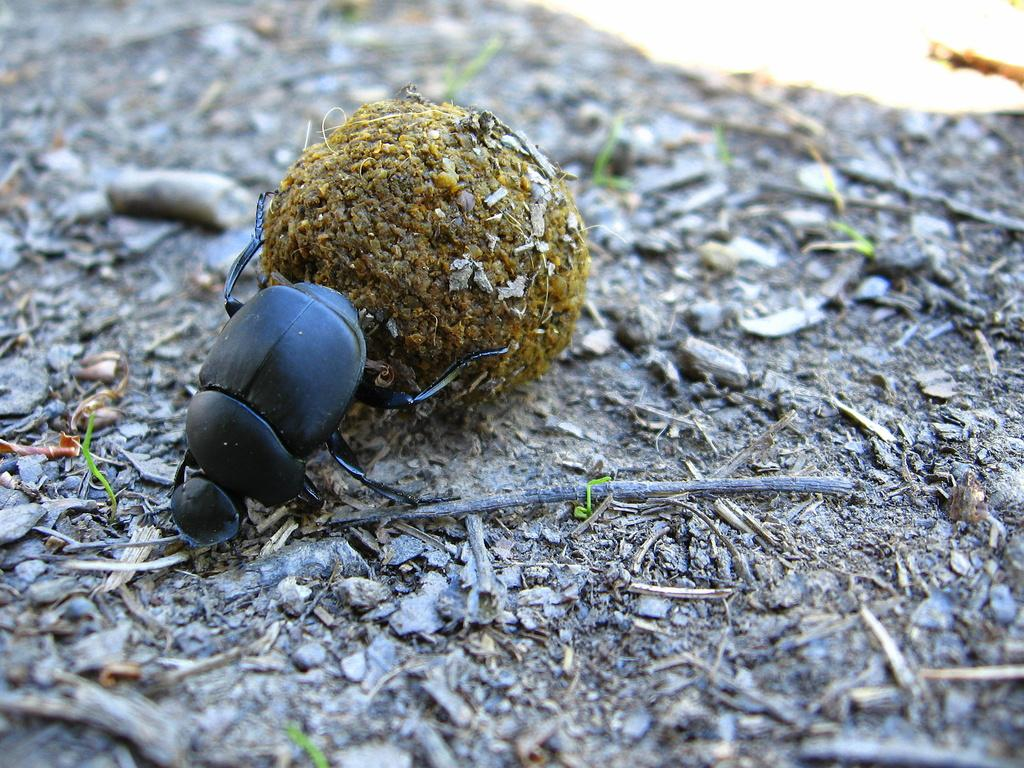What type of creatures are present in the image? There are insects in the image. What are the insects holding in their legs? The insects are holding ball-type objects with their legs. What type of potato is visible in the image? There is no potato present in the image. How does the bottle interact with the insects in the image? There is no bottle present in the image. 